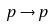<formula> <loc_0><loc_0><loc_500><loc_500>p \rightarrow p</formula> 